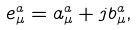Convert formula to latex. <formula><loc_0><loc_0><loc_500><loc_500>e _ { \mu } ^ { a } = a _ { \mu } ^ { a } + j b _ { \mu } ^ { a } ,</formula> 